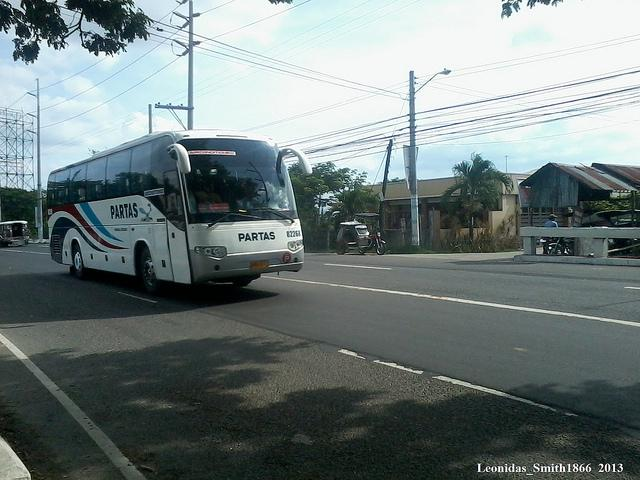What type of lines are located above the street? Please explain your reasoning. power. The lines above are for electricity. 